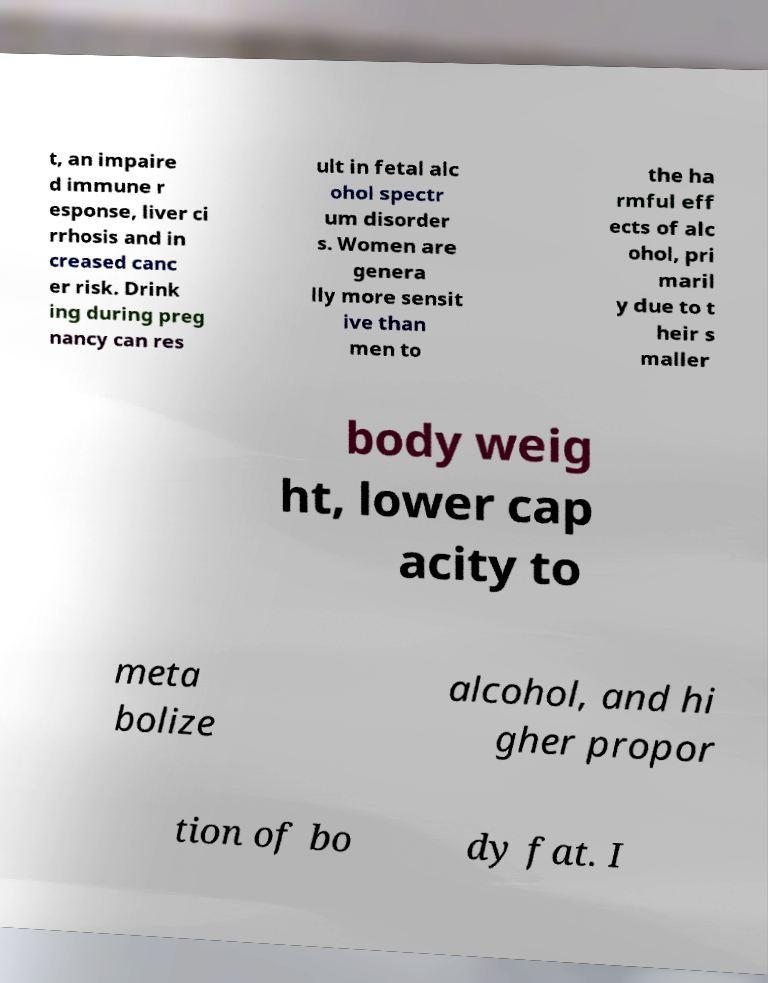Please identify and transcribe the text found in this image. t, an impaire d immune r esponse, liver ci rrhosis and in creased canc er risk. Drink ing during preg nancy can res ult in fetal alc ohol spectr um disorder s. Women are genera lly more sensit ive than men to the ha rmful eff ects of alc ohol, pri maril y due to t heir s maller body weig ht, lower cap acity to meta bolize alcohol, and hi gher propor tion of bo dy fat. I 